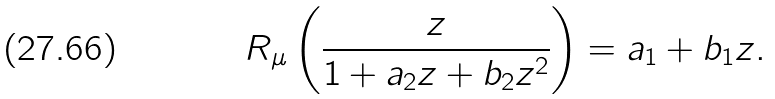<formula> <loc_0><loc_0><loc_500><loc_500>R _ { \mu } \left ( \frac { z } { 1 + a _ { 2 } z + b _ { 2 } z ^ { 2 } } \right ) = a _ { 1 } + b _ { 1 } z .</formula> 